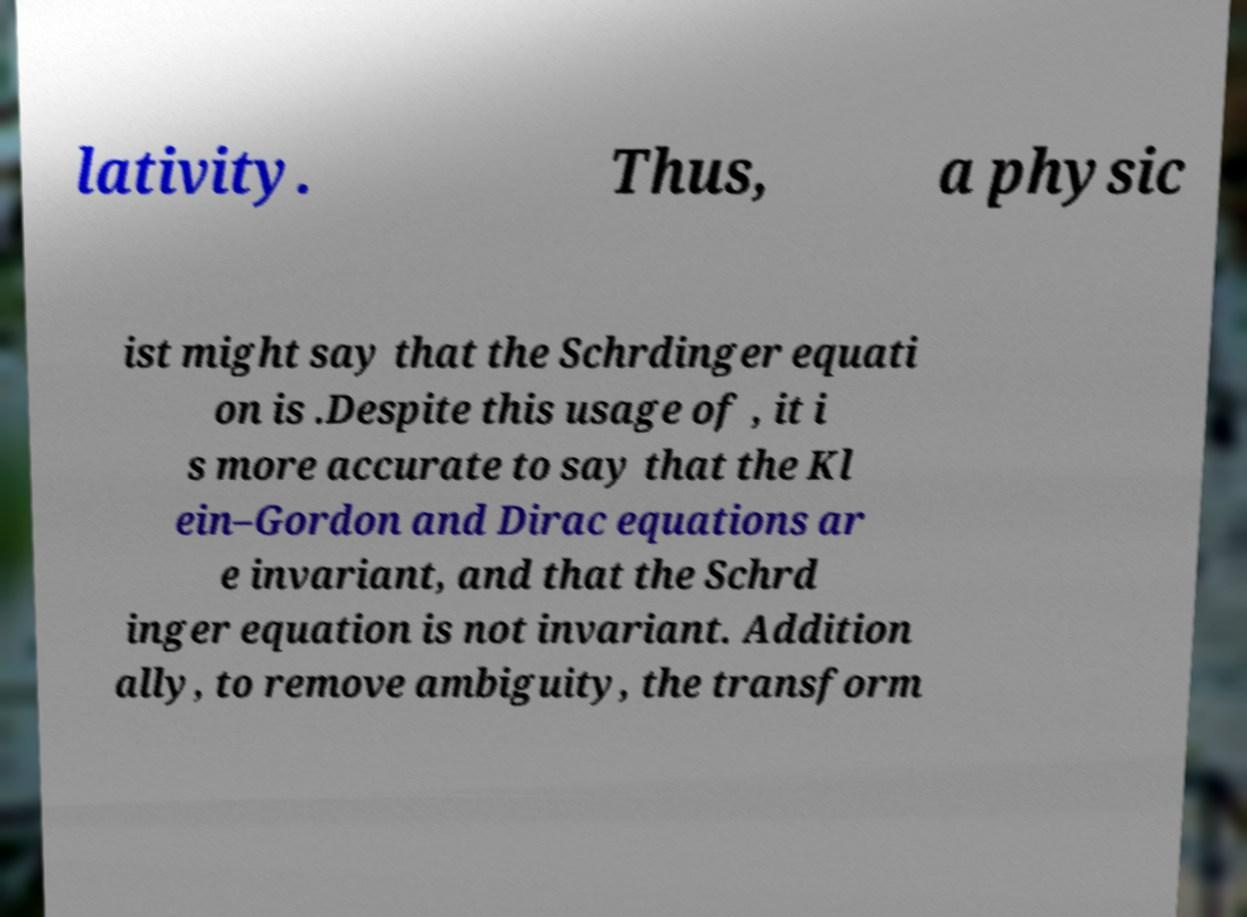For documentation purposes, I need the text within this image transcribed. Could you provide that? lativity. Thus, a physic ist might say that the Schrdinger equati on is .Despite this usage of , it i s more accurate to say that the Kl ein–Gordon and Dirac equations ar e invariant, and that the Schrd inger equation is not invariant. Addition ally, to remove ambiguity, the transform 